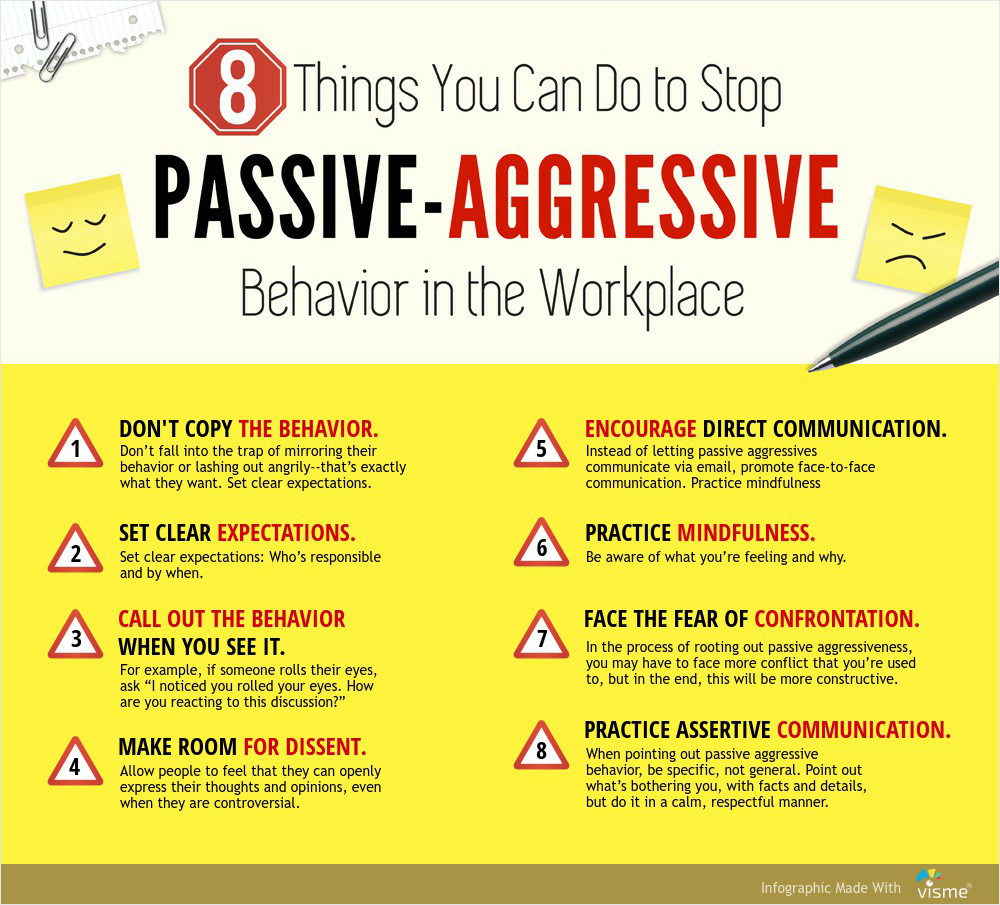Considering the explanations provided for each point, which two strategies could be considered closely related in terms of their approach to addressing passive-aggressive behavior? Strategies 1 and 8, "DON'T COPY THE BEHAVIOR" and "PRACTICE ASSERTIVE COMMUNICATION," can be considered closely related in how they address passive-aggressive behavior. Both strategies emphasize the importance of maintaining a calm, respectful, and direct communication style. Strategy 1 discourages mirroring passive-aggressive actions and advocates for setting clear expectations, while Strategy 8 highlights the need for specific and respectful communication to address issues, which helps prevent the escalation of passive aggression. Together, these strategies promote a direct, calm, and respectful approach to communication, aiding in de-escalating potential conflicts and fostering a more positive workplace environment. 